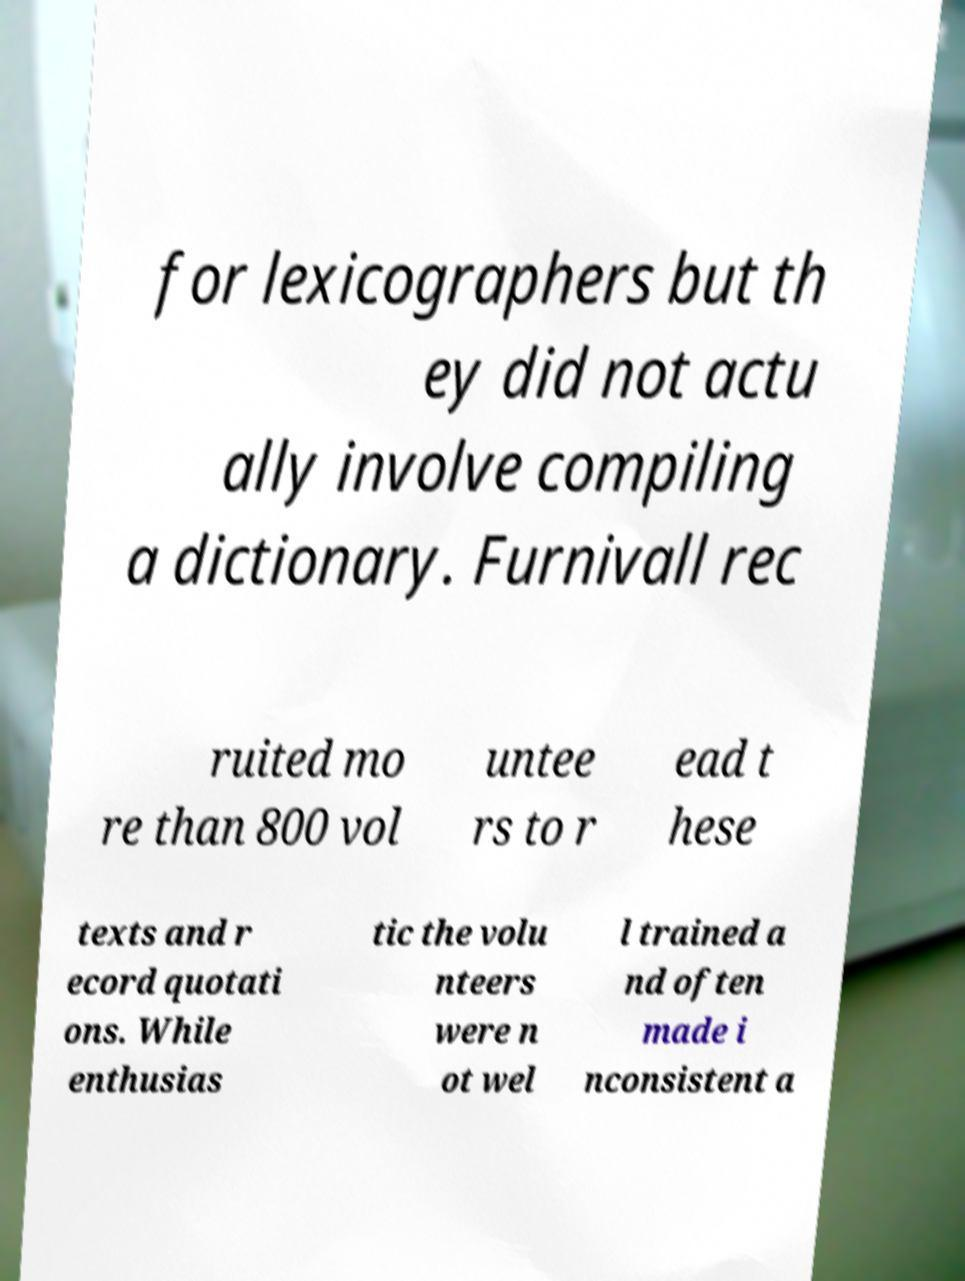I need the written content from this picture converted into text. Can you do that? for lexicographers but th ey did not actu ally involve compiling a dictionary. Furnivall rec ruited mo re than 800 vol untee rs to r ead t hese texts and r ecord quotati ons. While enthusias tic the volu nteers were n ot wel l trained a nd often made i nconsistent a 